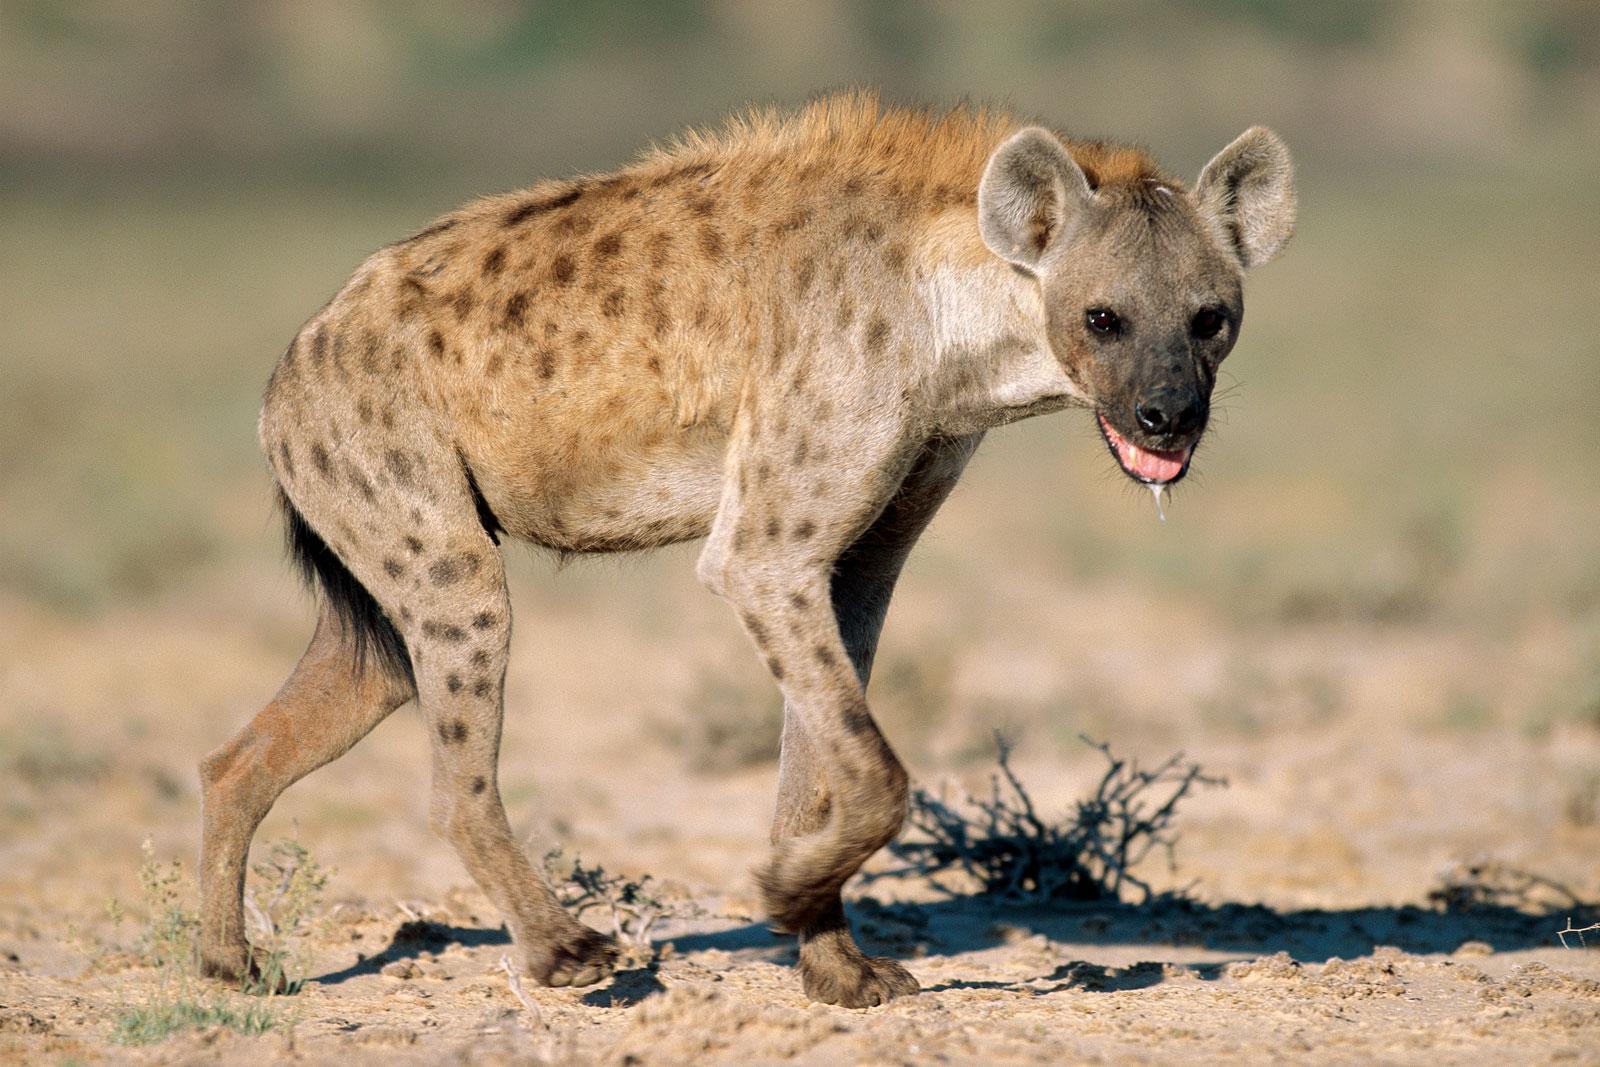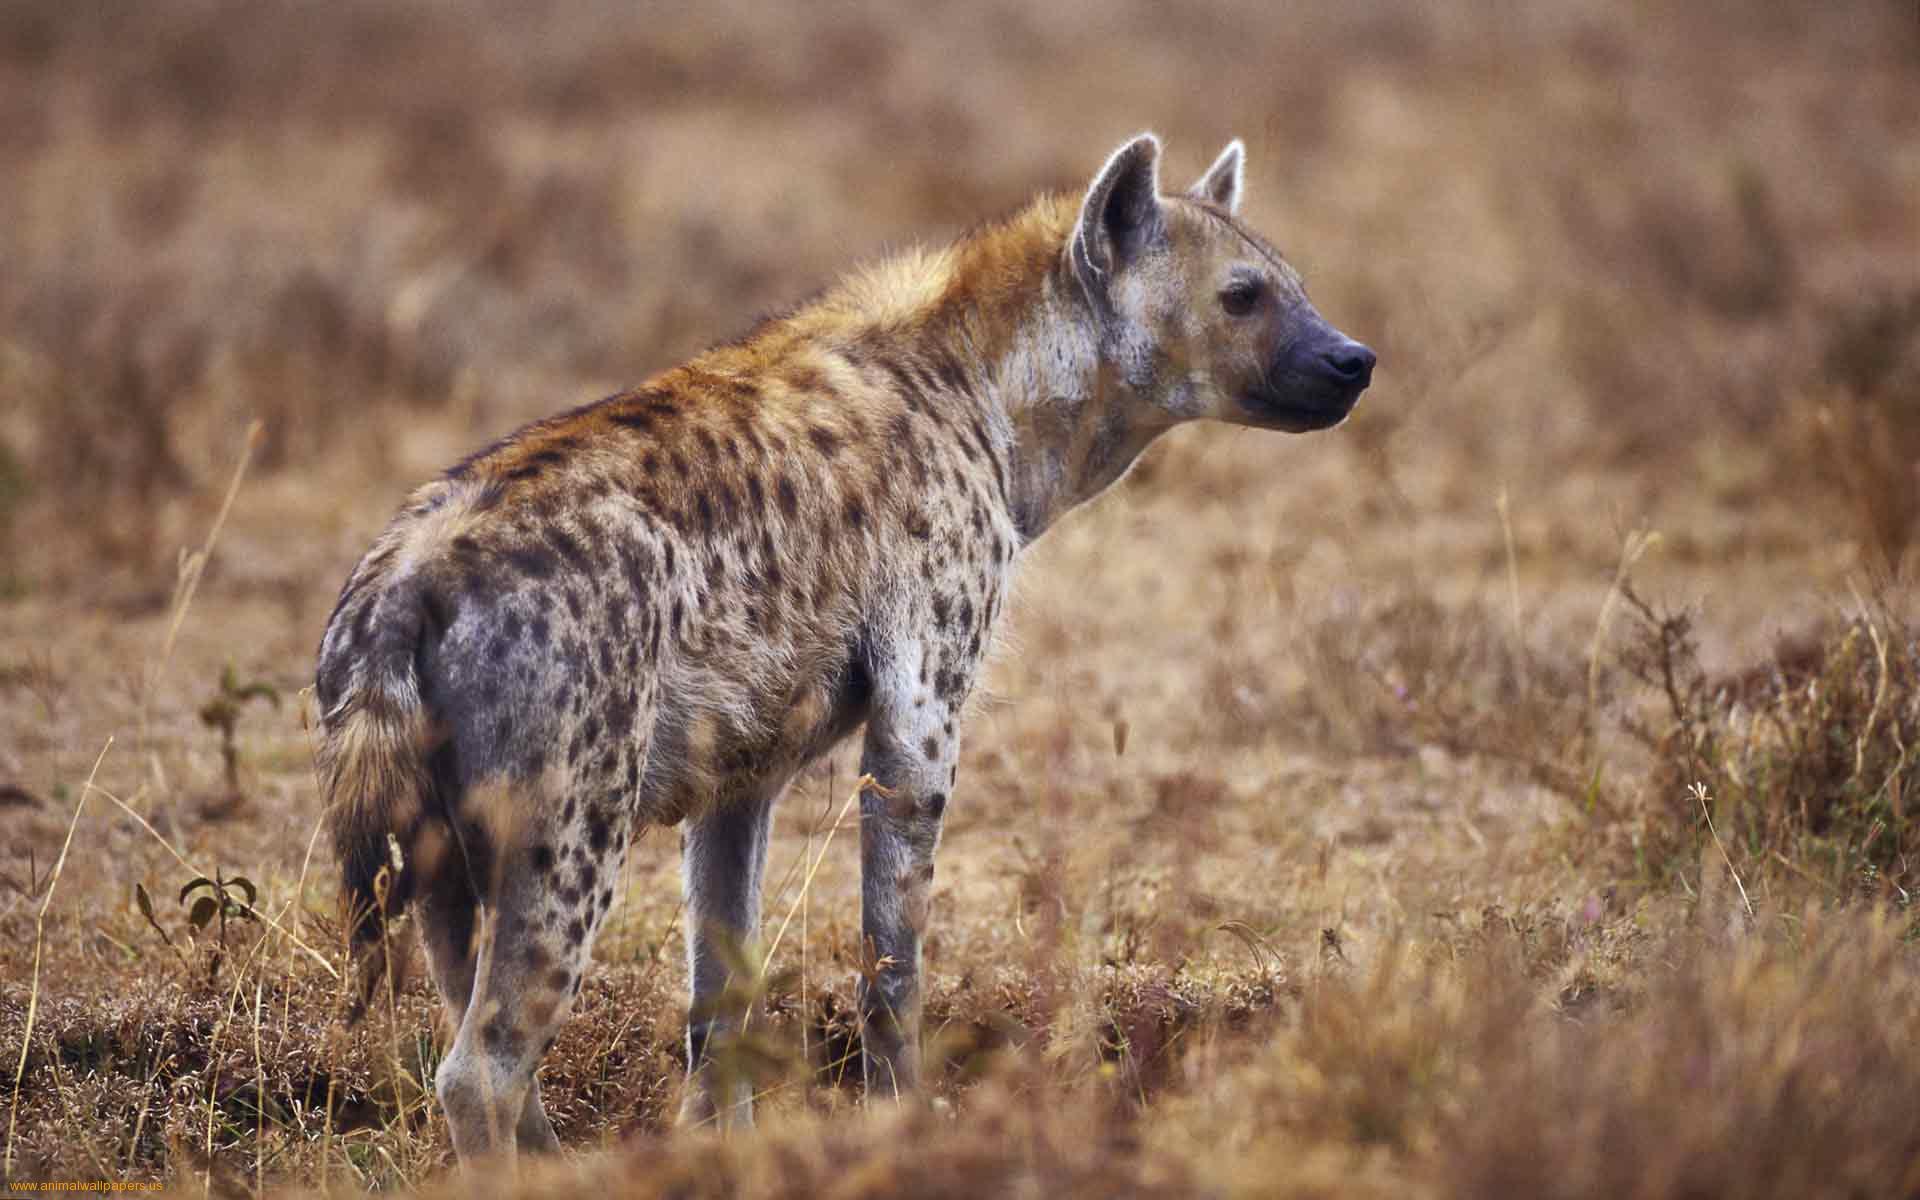The first image is the image on the left, the second image is the image on the right. Given the left and right images, does the statement "An image shows a hyena carrying prey in its jaws." hold true? Answer yes or no. No. 